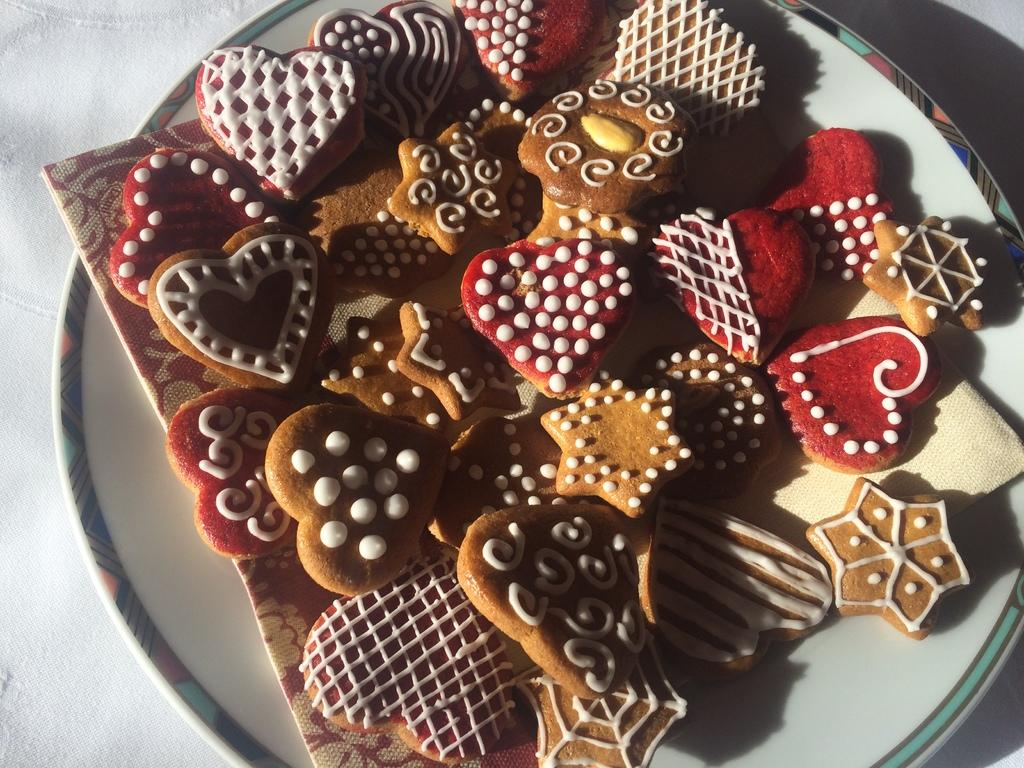What type of food can be seen in the image? There are biscuits in the image. How are the biscuits arranged or stored? The biscuits are in a white-colored plant. What is the color of the surface on which the plant is placed? The plant is on a white-colored surface. What type of haircut does the crow have in the image? There is no crow present in the image, so it is not possible to determine the type of haircut it might have. 